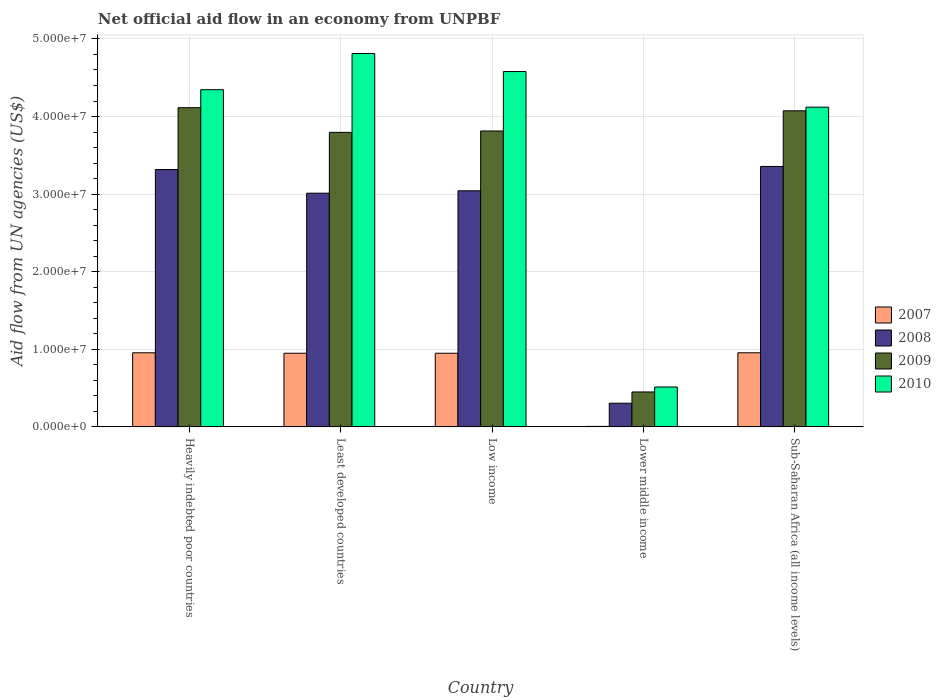How many groups of bars are there?
Keep it short and to the point. 5. What is the label of the 5th group of bars from the left?
Give a very brief answer. Sub-Saharan Africa (all income levels). What is the net official aid flow in 2008 in Sub-Saharan Africa (all income levels)?
Your answer should be compact. 3.36e+07. Across all countries, what is the maximum net official aid flow in 2009?
Your answer should be compact. 4.11e+07. Across all countries, what is the minimum net official aid flow in 2010?
Ensure brevity in your answer.  5.14e+06. In which country was the net official aid flow in 2007 maximum?
Keep it short and to the point. Heavily indebted poor countries. In which country was the net official aid flow in 2008 minimum?
Ensure brevity in your answer.  Lower middle income. What is the total net official aid flow in 2009 in the graph?
Make the answer very short. 1.62e+08. What is the difference between the net official aid flow in 2008 in Least developed countries and that in Sub-Saharan Africa (all income levels)?
Make the answer very short. -3.45e+06. What is the difference between the net official aid flow in 2010 in Heavily indebted poor countries and the net official aid flow in 2008 in Least developed countries?
Offer a very short reply. 1.33e+07. What is the average net official aid flow in 2009 per country?
Make the answer very short. 3.25e+07. What is the difference between the net official aid flow of/in 2010 and net official aid flow of/in 2009 in Low income?
Provide a succinct answer. 7.66e+06. In how many countries, is the net official aid flow in 2010 greater than 20000000 US$?
Offer a terse response. 4. What is the ratio of the net official aid flow in 2007 in Heavily indebted poor countries to that in Least developed countries?
Provide a succinct answer. 1.01. What is the difference between the highest and the second highest net official aid flow in 2007?
Ensure brevity in your answer.  6.00e+04. What is the difference between the highest and the lowest net official aid flow in 2009?
Provide a short and direct response. 3.66e+07. In how many countries, is the net official aid flow in 2009 greater than the average net official aid flow in 2009 taken over all countries?
Keep it short and to the point. 4. Is the sum of the net official aid flow in 2010 in Least developed countries and Sub-Saharan Africa (all income levels) greater than the maximum net official aid flow in 2009 across all countries?
Your response must be concise. Yes. Is it the case that in every country, the sum of the net official aid flow in 2008 and net official aid flow in 2007 is greater than the sum of net official aid flow in 2009 and net official aid flow in 2010?
Ensure brevity in your answer.  No. What does the 1st bar from the left in Sub-Saharan Africa (all income levels) represents?
Your answer should be compact. 2007. What does the 2nd bar from the right in Lower middle income represents?
Your answer should be very brief. 2009. How many bars are there?
Make the answer very short. 20. Are all the bars in the graph horizontal?
Provide a succinct answer. No. What is the difference between two consecutive major ticks on the Y-axis?
Provide a succinct answer. 1.00e+07. Where does the legend appear in the graph?
Provide a short and direct response. Center right. How are the legend labels stacked?
Your answer should be very brief. Vertical. What is the title of the graph?
Make the answer very short. Net official aid flow in an economy from UNPBF. Does "2014" appear as one of the legend labels in the graph?
Offer a terse response. No. What is the label or title of the Y-axis?
Offer a very short reply. Aid flow from UN agencies (US$). What is the Aid flow from UN agencies (US$) of 2007 in Heavily indebted poor countries?
Your response must be concise. 9.55e+06. What is the Aid flow from UN agencies (US$) of 2008 in Heavily indebted poor countries?
Ensure brevity in your answer.  3.32e+07. What is the Aid flow from UN agencies (US$) in 2009 in Heavily indebted poor countries?
Give a very brief answer. 4.11e+07. What is the Aid flow from UN agencies (US$) in 2010 in Heavily indebted poor countries?
Your answer should be compact. 4.35e+07. What is the Aid flow from UN agencies (US$) in 2007 in Least developed countries?
Your answer should be very brief. 9.49e+06. What is the Aid flow from UN agencies (US$) of 2008 in Least developed countries?
Give a very brief answer. 3.01e+07. What is the Aid flow from UN agencies (US$) in 2009 in Least developed countries?
Keep it short and to the point. 3.80e+07. What is the Aid flow from UN agencies (US$) in 2010 in Least developed countries?
Give a very brief answer. 4.81e+07. What is the Aid flow from UN agencies (US$) in 2007 in Low income?
Give a very brief answer. 9.49e+06. What is the Aid flow from UN agencies (US$) in 2008 in Low income?
Make the answer very short. 3.04e+07. What is the Aid flow from UN agencies (US$) in 2009 in Low income?
Offer a very short reply. 3.81e+07. What is the Aid flow from UN agencies (US$) in 2010 in Low income?
Your answer should be compact. 4.58e+07. What is the Aid flow from UN agencies (US$) in 2008 in Lower middle income?
Your answer should be very brief. 3.05e+06. What is the Aid flow from UN agencies (US$) of 2009 in Lower middle income?
Keep it short and to the point. 4.50e+06. What is the Aid flow from UN agencies (US$) in 2010 in Lower middle income?
Offer a very short reply. 5.14e+06. What is the Aid flow from UN agencies (US$) of 2007 in Sub-Saharan Africa (all income levels)?
Ensure brevity in your answer.  9.55e+06. What is the Aid flow from UN agencies (US$) of 2008 in Sub-Saharan Africa (all income levels)?
Give a very brief answer. 3.36e+07. What is the Aid flow from UN agencies (US$) in 2009 in Sub-Saharan Africa (all income levels)?
Your response must be concise. 4.07e+07. What is the Aid flow from UN agencies (US$) of 2010 in Sub-Saharan Africa (all income levels)?
Your answer should be very brief. 4.12e+07. Across all countries, what is the maximum Aid flow from UN agencies (US$) in 2007?
Your response must be concise. 9.55e+06. Across all countries, what is the maximum Aid flow from UN agencies (US$) of 2008?
Offer a terse response. 3.36e+07. Across all countries, what is the maximum Aid flow from UN agencies (US$) in 2009?
Your answer should be very brief. 4.11e+07. Across all countries, what is the maximum Aid flow from UN agencies (US$) of 2010?
Keep it short and to the point. 4.81e+07. Across all countries, what is the minimum Aid flow from UN agencies (US$) in 2008?
Your answer should be compact. 3.05e+06. Across all countries, what is the minimum Aid flow from UN agencies (US$) in 2009?
Offer a terse response. 4.50e+06. Across all countries, what is the minimum Aid flow from UN agencies (US$) of 2010?
Provide a short and direct response. 5.14e+06. What is the total Aid flow from UN agencies (US$) of 2007 in the graph?
Your response must be concise. 3.81e+07. What is the total Aid flow from UN agencies (US$) of 2008 in the graph?
Your answer should be compact. 1.30e+08. What is the total Aid flow from UN agencies (US$) of 2009 in the graph?
Offer a very short reply. 1.62e+08. What is the total Aid flow from UN agencies (US$) in 2010 in the graph?
Give a very brief answer. 1.84e+08. What is the difference between the Aid flow from UN agencies (US$) in 2008 in Heavily indebted poor countries and that in Least developed countries?
Give a very brief answer. 3.05e+06. What is the difference between the Aid flow from UN agencies (US$) in 2009 in Heavily indebted poor countries and that in Least developed countries?
Provide a short and direct response. 3.18e+06. What is the difference between the Aid flow from UN agencies (US$) in 2010 in Heavily indebted poor countries and that in Least developed countries?
Your response must be concise. -4.66e+06. What is the difference between the Aid flow from UN agencies (US$) in 2008 in Heavily indebted poor countries and that in Low income?
Your answer should be very brief. 2.74e+06. What is the difference between the Aid flow from UN agencies (US$) in 2009 in Heavily indebted poor countries and that in Low income?
Make the answer very short. 3.00e+06. What is the difference between the Aid flow from UN agencies (US$) of 2010 in Heavily indebted poor countries and that in Low income?
Offer a terse response. -2.34e+06. What is the difference between the Aid flow from UN agencies (US$) of 2007 in Heavily indebted poor countries and that in Lower middle income?
Your answer should be compact. 9.49e+06. What is the difference between the Aid flow from UN agencies (US$) in 2008 in Heavily indebted poor countries and that in Lower middle income?
Your response must be concise. 3.01e+07. What is the difference between the Aid flow from UN agencies (US$) of 2009 in Heavily indebted poor countries and that in Lower middle income?
Ensure brevity in your answer.  3.66e+07. What is the difference between the Aid flow from UN agencies (US$) in 2010 in Heavily indebted poor countries and that in Lower middle income?
Offer a terse response. 3.83e+07. What is the difference between the Aid flow from UN agencies (US$) in 2008 in Heavily indebted poor countries and that in Sub-Saharan Africa (all income levels)?
Offer a terse response. -4.00e+05. What is the difference between the Aid flow from UN agencies (US$) in 2009 in Heavily indebted poor countries and that in Sub-Saharan Africa (all income levels)?
Provide a succinct answer. 4.00e+05. What is the difference between the Aid flow from UN agencies (US$) of 2010 in Heavily indebted poor countries and that in Sub-Saharan Africa (all income levels)?
Your answer should be compact. 2.25e+06. What is the difference between the Aid flow from UN agencies (US$) of 2007 in Least developed countries and that in Low income?
Your response must be concise. 0. What is the difference between the Aid flow from UN agencies (US$) of 2008 in Least developed countries and that in Low income?
Your answer should be compact. -3.10e+05. What is the difference between the Aid flow from UN agencies (US$) of 2009 in Least developed countries and that in Low income?
Give a very brief answer. -1.80e+05. What is the difference between the Aid flow from UN agencies (US$) of 2010 in Least developed countries and that in Low income?
Your response must be concise. 2.32e+06. What is the difference between the Aid flow from UN agencies (US$) in 2007 in Least developed countries and that in Lower middle income?
Make the answer very short. 9.43e+06. What is the difference between the Aid flow from UN agencies (US$) in 2008 in Least developed countries and that in Lower middle income?
Provide a succinct answer. 2.71e+07. What is the difference between the Aid flow from UN agencies (US$) of 2009 in Least developed countries and that in Lower middle income?
Ensure brevity in your answer.  3.35e+07. What is the difference between the Aid flow from UN agencies (US$) of 2010 in Least developed countries and that in Lower middle income?
Your answer should be very brief. 4.30e+07. What is the difference between the Aid flow from UN agencies (US$) of 2007 in Least developed countries and that in Sub-Saharan Africa (all income levels)?
Offer a very short reply. -6.00e+04. What is the difference between the Aid flow from UN agencies (US$) of 2008 in Least developed countries and that in Sub-Saharan Africa (all income levels)?
Offer a very short reply. -3.45e+06. What is the difference between the Aid flow from UN agencies (US$) in 2009 in Least developed countries and that in Sub-Saharan Africa (all income levels)?
Your response must be concise. -2.78e+06. What is the difference between the Aid flow from UN agencies (US$) in 2010 in Least developed countries and that in Sub-Saharan Africa (all income levels)?
Your answer should be compact. 6.91e+06. What is the difference between the Aid flow from UN agencies (US$) of 2007 in Low income and that in Lower middle income?
Your answer should be very brief. 9.43e+06. What is the difference between the Aid flow from UN agencies (US$) of 2008 in Low income and that in Lower middle income?
Offer a very short reply. 2.74e+07. What is the difference between the Aid flow from UN agencies (US$) in 2009 in Low income and that in Lower middle income?
Give a very brief answer. 3.36e+07. What is the difference between the Aid flow from UN agencies (US$) of 2010 in Low income and that in Lower middle income?
Your response must be concise. 4.07e+07. What is the difference between the Aid flow from UN agencies (US$) in 2007 in Low income and that in Sub-Saharan Africa (all income levels)?
Your response must be concise. -6.00e+04. What is the difference between the Aid flow from UN agencies (US$) in 2008 in Low income and that in Sub-Saharan Africa (all income levels)?
Your answer should be compact. -3.14e+06. What is the difference between the Aid flow from UN agencies (US$) of 2009 in Low income and that in Sub-Saharan Africa (all income levels)?
Keep it short and to the point. -2.60e+06. What is the difference between the Aid flow from UN agencies (US$) in 2010 in Low income and that in Sub-Saharan Africa (all income levels)?
Your response must be concise. 4.59e+06. What is the difference between the Aid flow from UN agencies (US$) of 2007 in Lower middle income and that in Sub-Saharan Africa (all income levels)?
Your answer should be very brief. -9.49e+06. What is the difference between the Aid flow from UN agencies (US$) in 2008 in Lower middle income and that in Sub-Saharan Africa (all income levels)?
Keep it short and to the point. -3.05e+07. What is the difference between the Aid flow from UN agencies (US$) of 2009 in Lower middle income and that in Sub-Saharan Africa (all income levels)?
Your answer should be very brief. -3.62e+07. What is the difference between the Aid flow from UN agencies (US$) in 2010 in Lower middle income and that in Sub-Saharan Africa (all income levels)?
Keep it short and to the point. -3.61e+07. What is the difference between the Aid flow from UN agencies (US$) of 2007 in Heavily indebted poor countries and the Aid flow from UN agencies (US$) of 2008 in Least developed countries?
Give a very brief answer. -2.06e+07. What is the difference between the Aid flow from UN agencies (US$) in 2007 in Heavily indebted poor countries and the Aid flow from UN agencies (US$) in 2009 in Least developed countries?
Keep it short and to the point. -2.84e+07. What is the difference between the Aid flow from UN agencies (US$) of 2007 in Heavily indebted poor countries and the Aid flow from UN agencies (US$) of 2010 in Least developed countries?
Offer a very short reply. -3.86e+07. What is the difference between the Aid flow from UN agencies (US$) in 2008 in Heavily indebted poor countries and the Aid flow from UN agencies (US$) in 2009 in Least developed countries?
Offer a very short reply. -4.79e+06. What is the difference between the Aid flow from UN agencies (US$) of 2008 in Heavily indebted poor countries and the Aid flow from UN agencies (US$) of 2010 in Least developed countries?
Your answer should be very brief. -1.50e+07. What is the difference between the Aid flow from UN agencies (US$) of 2009 in Heavily indebted poor countries and the Aid flow from UN agencies (US$) of 2010 in Least developed countries?
Provide a short and direct response. -6.98e+06. What is the difference between the Aid flow from UN agencies (US$) of 2007 in Heavily indebted poor countries and the Aid flow from UN agencies (US$) of 2008 in Low income?
Provide a short and direct response. -2.09e+07. What is the difference between the Aid flow from UN agencies (US$) of 2007 in Heavily indebted poor countries and the Aid flow from UN agencies (US$) of 2009 in Low income?
Your answer should be very brief. -2.86e+07. What is the difference between the Aid flow from UN agencies (US$) in 2007 in Heavily indebted poor countries and the Aid flow from UN agencies (US$) in 2010 in Low income?
Provide a short and direct response. -3.62e+07. What is the difference between the Aid flow from UN agencies (US$) in 2008 in Heavily indebted poor countries and the Aid flow from UN agencies (US$) in 2009 in Low income?
Your response must be concise. -4.97e+06. What is the difference between the Aid flow from UN agencies (US$) of 2008 in Heavily indebted poor countries and the Aid flow from UN agencies (US$) of 2010 in Low income?
Offer a very short reply. -1.26e+07. What is the difference between the Aid flow from UN agencies (US$) in 2009 in Heavily indebted poor countries and the Aid flow from UN agencies (US$) in 2010 in Low income?
Provide a succinct answer. -4.66e+06. What is the difference between the Aid flow from UN agencies (US$) of 2007 in Heavily indebted poor countries and the Aid flow from UN agencies (US$) of 2008 in Lower middle income?
Provide a succinct answer. 6.50e+06. What is the difference between the Aid flow from UN agencies (US$) in 2007 in Heavily indebted poor countries and the Aid flow from UN agencies (US$) in 2009 in Lower middle income?
Your answer should be compact. 5.05e+06. What is the difference between the Aid flow from UN agencies (US$) in 2007 in Heavily indebted poor countries and the Aid flow from UN agencies (US$) in 2010 in Lower middle income?
Provide a succinct answer. 4.41e+06. What is the difference between the Aid flow from UN agencies (US$) in 2008 in Heavily indebted poor countries and the Aid flow from UN agencies (US$) in 2009 in Lower middle income?
Give a very brief answer. 2.87e+07. What is the difference between the Aid flow from UN agencies (US$) in 2008 in Heavily indebted poor countries and the Aid flow from UN agencies (US$) in 2010 in Lower middle income?
Your answer should be very brief. 2.80e+07. What is the difference between the Aid flow from UN agencies (US$) in 2009 in Heavily indebted poor countries and the Aid flow from UN agencies (US$) in 2010 in Lower middle income?
Ensure brevity in your answer.  3.60e+07. What is the difference between the Aid flow from UN agencies (US$) of 2007 in Heavily indebted poor countries and the Aid flow from UN agencies (US$) of 2008 in Sub-Saharan Africa (all income levels)?
Ensure brevity in your answer.  -2.40e+07. What is the difference between the Aid flow from UN agencies (US$) in 2007 in Heavily indebted poor countries and the Aid flow from UN agencies (US$) in 2009 in Sub-Saharan Africa (all income levels)?
Your answer should be very brief. -3.12e+07. What is the difference between the Aid flow from UN agencies (US$) of 2007 in Heavily indebted poor countries and the Aid flow from UN agencies (US$) of 2010 in Sub-Saharan Africa (all income levels)?
Ensure brevity in your answer.  -3.17e+07. What is the difference between the Aid flow from UN agencies (US$) in 2008 in Heavily indebted poor countries and the Aid flow from UN agencies (US$) in 2009 in Sub-Saharan Africa (all income levels)?
Ensure brevity in your answer.  -7.57e+06. What is the difference between the Aid flow from UN agencies (US$) in 2008 in Heavily indebted poor countries and the Aid flow from UN agencies (US$) in 2010 in Sub-Saharan Africa (all income levels)?
Offer a terse response. -8.04e+06. What is the difference between the Aid flow from UN agencies (US$) of 2009 in Heavily indebted poor countries and the Aid flow from UN agencies (US$) of 2010 in Sub-Saharan Africa (all income levels)?
Provide a short and direct response. -7.00e+04. What is the difference between the Aid flow from UN agencies (US$) in 2007 in Least developed countries and the Aid flow from UN agencies (US$) in 2008 in Low income?
Keep it short and to the point. -2.09e+07. What is the difference between the Aid flow from UN agencies (US$) in 2007 in Least developed countries and the Aid flow from UN agencies (US$) in 2009 in Low income?
Ensure brevity in your answer.  -2.86e+07. What is the difference between the Aid flow from UN agencies (US$) of 2007 in Least developed countries and the Aid flow from UN agencies (US$) of 2010 in Low income?
Make the answer very short. -3.63e+07. What is the difference between the Aid flow from UN agencies (US$) in 2008 in Least developed countries and the Aid flow from UN agencies (US$) in 2009 in Low income?
Ensure brevity in your answer.  -8.02e+06. What is the difference between the Aid flow from UN agencies (US$) of 2008 in Least developed countries and the Aid flow from UN agencies (US$) of 2010 in Low income?
Keep it short and to the point. -1.57e+07. What is the difference between the Aid flow from UN agencies (US$) in 2009 in Least developed countries and the Aid flow from UN agencies (US$) in 2010 in Low income?
Your response must be concise. -7.84e+06. What is the difference between the Aid flow from UN agencies (US$) of 2007 in Least developed countries and the Aid flow from UN agencies (US$) of 2008 in Lower middle income?
Your response must be concise. 6.44e+06. What is the difference between the Aid flow from UN agencies (US$) of 2007 in Least developed countries and the Aid flow from UN agencies (US$) of 2009 in Lower middle income?
Your response must be concise. 4.99e+06. What is the difference between the Aid flow from UN agencies (US$) in 2007 in Least developed countries and the Aid flow from UN agencies (US$) in 2010 in Lower middle income?
Offer a very short reply. 4.35e+06. What is the difference between the Aid flow from UN agencies (US$) in 2008 in Least developed countries and the Aid flow from UN agencies (US$) in 2009 in Lower middle income?
Your answer should be very brief. 2.56e+07. What is the difference between the Aid flow from UN agencies (US$) of 2008 in Least developed countries and the Aid flow from UN agencies (US$) of 2010 in Lower middle income?
Give a very brief answer. 2.50e+07. What is the difference between the Aid flow from UN agencies (US$) of 2009 in Least developed countries and the Aid flow from UN agencies (US$) of 2010 in Lower middle income?
Your answer should be very brief. 3.28e+07. What is the difference between the Aid flow from UN agencies (US$) of 2007 in Least developed countries and the Aid flow from UN agencies (US$) of 2008 in Sub-Saharan Africa (all income levels)?
Ensure brevity in your answer.  -2.41e+07. What is the difference between the Aid flow from UN agencies (US$) of 2007 in Least developed countries and the Aid flow from UN agencies (US$) of 2009 in Sub-Saharan Africa (all income levels)?
Provide a short and direct response. -3.12e+07. What is the difference between the Aid flow from UN agencies (US$) of 2007 in Least developed countries and the Aid flow from UN agencies (US$) of 2010 in Sub-Saharan Africa (all income levels)?
Give a very brief answer. -3.17e+07. What is the difference between the Aid flow from UN agencies (US$) of 2008 in Least developed countries and the Aid flow from UN agencies (US$) of 2009 in Sub-Saharan Africa (all income levels)?
Make the answer very short. -1.06e+07. What is the difference between the Aid flow from UN agencies (US$) of 2008 in Least developed countries and the Aid flow from UN agencies (US$) of 2010 in Sub-Saharan Africa (all income levels)?
Provide a short and direct response. -1.11e+07. What is the difference between the Aid flow from UN agencies (US$) in 2009 in Least developed countries and the Aid flow from UN agencies (US$) in 2010 in Sub-Saharan Africa (all income levels)?
Offer a terse response. -3.25e+06. What is the difference between the Aid flow from UN agencies (US$) of 2007 in Low income and the Aid flow from UN agencies (US$) of 2008 in Lower middle income?
Ensure brevity in your answer.  6.44e+06. What is the difference between the Aid flow from UN agencies (US$) of 2007 in Low income and the Aid flow from UN agencies (US$) of 2009 in Lower middle income?
Make the answer very short. 4.99e+06. What is the difference between the Aid flow from UN agencies (US$) in 2007 in Low income and the Aid flow from UN agencies (US$) in 2010 in Lower middle income?
Offer a very short reply. 4.35e+06. What is the difference between the Aid flow from UN agencies (US$) in 2008 in Low income and the Aid flow from UN agencies (US$) in 2009 in Lower middle income?
Provide a succinct answer. 2.59e+07. What is the difference between the Aid flow from UN agencies (US$) of 2008 in Low income and the Aid flow from UN agencies (US$) of 2010 in Lower middle income?
Your answer should be very brief. 2.53e+07. What is the difference between the Aid flow from UN agencies (US$) of 2009 in Low income and the Aid flow from UN agencies (US$) of 2010 in Lower middle income?
Your answer should be compact. 3.30e+07. What is the difference between the Aid flow from UN agencies (US$) of 2007 in Low income and the Aid flow from UN agencies (US$) of 2008 in Sub-Saharan Africa (all income levels)?
Offer a terse response. -2.41e+07. What is the difference between the Aid flow from UN agencies (US$) in 2007 in Low income and the Aid flow from UN agencies (US$) in 2009 in Sub-Saharan Africa (all income levels)?
Keep it short and to the point. -3.12e+07. What is the difference between the Aid flow from UN agencies (US$) of 2007 in Low income and the Aid flow from UN agencies (US$) of 2010 in Sub-Saharan Africa (all income levels)?
Your answer should be very brief. -3.17e+07. What is the difference between the Aid flow from UN agencies (US$) of 2008 in Low income and the Aid flow from UN agencies (US$) of 2009 in Sub-Saharan Africa (all income levels)?
Give a very brief answer. -1.03e+07. What is the difference between the Aid flow from UN agencies (US$) of 2008 in Low income and the Aid flow from UN agencies (US$) of 2010 in Sub-Saharan Africa (all income levels)?
Give a very brief answer. -1.08e+07. What is the difference between the Aid flow from UN agencies (US$) of 2009 in Low income and the Aid flow from UN agencies (US$) of 2010 in Sub-Saharan Africa (all income levels)?
Make the answer very short. -3.07e+06. What is the difference between the Aid flow from UN agencies (US$) of 2007 in Lower middle income and the Aid flow from UN agencies (US$) of 2008 in Sub-Saharan Africa (all income levels)?
Keep it short and to the point. -3.35e+07. What is the difference between the Aid flow from UN agencies (US$) of 2007 in Lower middle income and the Aid flow from UN agencies (US$) of 2009 in Sub-Saharan Africa (all income levels)?
Offer a terse response. -4.07e+07. What is the difference between the Aid flow from UN agencies (US$) of 2007 in Lower middle income and the Aid flow from UN agencies (US$) of 2010 in Sub-Saharan Africa (all income levels)?
Give a very brief answer. -4.12e+07. What is the difference between the Aid flow from UN agencies (US$) of 2008 in Lower middle income and the Aid flow from UN agencies (US$) of 2009 in Sub-Saharan Africa (all income levels)?
Offer a very short reply. -3.77e+07. What is the difference between the Aid flow from UN agencies (US$) of 2008 in Lower middle income and the Aid flow from UN agencies (US$) of 2010 in Sub-Saharan Africa (all income levels)?
Offer a very short reply. -3.82e+07. What is the difference between the Aid flow from UN agencies (US$) in 2009 in Lower middle income and the Aid flow from UN agencies (US$) in 2010 in Sub-Saharan Africa (all income levels)?
Provide a succinct answer. -3.67e+07. What is the average Aid flow from UN agencies (US$) of 2007 per country?
Keep it short and to the point. 7.63e+06. What is the average Aid flow from UN agencies (US$) of 2008 per country?
Keep it short and to the point. 2.61e+07. What is the average Aid flow from UN agencies (US$) of 2009 per country?
Keep it short and to the point. 3.25e+07. What is the average Aid flow from UN agencies (US$) in 2010 per country?
Offer a very short reply. 3.67e+07. What is the difference between the Aid flow from UN agencies (US$) in 2007 and Aid flow from UN agencies (US$) in 2008 in Heavily indebted poor countries?
Your answer should be very brief. -2.36e+07. What is the difference between the Aid flow from UN agencies (US$) in 2007 and Aid flow from UN agencies (US$) in 2009 in Heavily indebted poor countries?
Your response must be concise. -3.16e+07. What is the difference between the Aid flow from UN agencies (US$) of 2007 and Aid flow from UN agencies (US$) of 2010 in Heavily indebted poor countries?
Ensure brevity in your answer.  -3.39e+07. What is the difference between the Aid flow from UN agencies (US$) in 2008 and Aid flow from UN agencies (US$) in 2009 in Heavily indebted poor countries?
Make the answer very short. -7.97e+06. What is the difference between the Aid flow from UN agencies (US$) of 2008 and Aid flow from UN agencies (US$) of 2010 in Heavily indebted poor countries?
Make the answer very short. -1.03e+07. What is the difference between the Aid flow from UN agencies (US$) of 2009 and Aid flow from UN agencies (US$) of 2010 in Heavily indebted poor countries?
Your response must be concise. -2.32e+06. What is the difference between the Aid flow from UN agencies (US$) in 2007 and Aid flow from UN agencies (US$) in 2008 in Least developed countries?
Your answer should be very brief. -2.06e+07. What is the difference between the Aid flow from UN agencies (US$) in 2007 and Aid flow from UN agencies (US$) in 2009 in Least developed countries?
Your answer should be very brief. -2.85e+07. What is the difference between the Aid flow from UN agencies (US$) of 2007 and Aid flow from UN agencies (US$) of 2010 in Least developed countries?
Provide a short and direct response. -3.86e+07. What is the difference between the Aid flow from UN agencies (US$) of 2008 and Aid flow from UN agencies (US$) of 2009 in Least developed countries?
Provide a succinct answer. -7.84e+06. What is the difference between the Aid flow from UN agencies (US$) in 2008 and Aid flow from UN agencies (US$) in 2010 in Least developed countries?
Your response must be concise. -1.80e+07. What is the difference between the Aid flow from UN agencies (US$) of 2009 and Aid flow from UN agencies (US$) of 2010 in Least developed countries?
Ensure brevity in your answer.  -1.02e+07. What is the difference between the Aid flow from UN agencies (US$) in 2007 and Aid flow from UN agencies (US$) in 2008 in Low income?
Make the answer very short. -2.09e+07. What is the difference between the Aid flow from UN agencies (US$) in 2007 and Aid flow from UN agencies (US$) in 2009 in Low income?
Provide a short and direct response. -2.86e+07. What is the difference between the Aid flow from UN agencies (US$) of 2007 and Aid flow from UN agencies (US$) of 2010 in Low income?
Your response must be concise. -3.63e+07. What is the difference between the Aid flow from UN agencies (US$) in 2008 and Aid flow from UN agencies (US$) in 2009 in Low income?
Your response must be concise. -7.71e+06. What is the difference between the Aid flow from UN agencies (US$) in 2008 and Aid flow from UN agencies (US$) in 2010 in Low income?
Your answer should be compact. -1.54e+07. What is the difference between the Aid flow from UN agencies (US$) in 2009 and Aid flow from UN agencies (US$) in 2010 in Low income?
Provide a succinct answer. -7.66e+06. What is the difference between the Aid flow from UN agencies (US$) of 2007 and Aid flow from UN agencies (US$) of 2008 in Lower middle income?
Your answer should be compact. -2.99e+06. What is the difference between the Aid flow from UN agencies (US$) in 2007 and Aid flow from UN agencies (US$) in 2009 in Lower middle income?
Ensure brevity in your answer.  -4.44e+06. What is the difference between the Aid flow from UN agencies (US$) in 2007 and Aid flow from UN agencies (US$) in 2010 in Lower middle income?
Give a very brief answer. -5.08e+06. What is the difference between the Aid flow from UN agencies (US$) in 2008 and Aid flow from UN agencies (US$) in 2009 in Lower middle income?
Your response must be concise. -1.45e+06. What is the difference between the Aid flow from UN agencies (US$) in 2008 and Aid flow from UN agencies (US$) in 2010 in Lower middle income?
Your answer should be very brief. -2.09e+06. What is the difference between the Aid flow from UN agencies (US$) of 2009 and Aid flow from UN agencies (US$) of 2010 in Lower middle income?
Offer a very short reply. -6.40e+05. What is the difference between the Aid flow from UN agencies (US$) in 2007 and Aid flow from UN agencies (US$) in 2008 in Sub-Saharan Africa (all income levels)?
Ensure brevity in your answer.  -2.40e+07. What is the difference between the Aid flow from UN agencies (US$) of 2007 and Aid flow from UN agencies (US$) of 2009 in Sub-Saharan Africa (all income levels)?
Give a very brief answer. -3.12e+07. What is the difference between the Aid flow from UN agencies (US$) in 2007 and Aid flow from UN agencies (US$) in 2010 in Sub-Saharan Africa (all income levels)?
Keep it short and to the point. -3.17e+07. What is the difference between the Aid flow from UN agencies (US$) of 2008 and Aid flow from UN agencies (US$) of 2009 in Sub-Saharan Africa (all income levels)?
Your answer should be very brief. -7.17e+06. What is the difference between the Aid flow from UN agencies (US$) of 2008 and Aid flow from UN agencies (US$) of 2010 in Sub-Saharan Africa (all income levels)?
Offer a very short reply. -7.64e+06. What is the difference between the Aid flow from UN agencies (US$) of 2009 and Aid flow from UN agencies (US$) of 2010 in Sub-Saharan Africa (all income levels)?
Provide a short and direct response. -4.70e+05. What is the ratio of the Aid flow from UN agencies (US$) in 2007 in Heavily indebted poor countries to that in Least developed countries?
Your response must be concise. 1.01. What is the ratio of the Aid flow from UN agencies (US$) in 2008 in Heavily indebted poor countries to that in Least developed countries?
Your answer should be compact. 1.1. What is the ratio of the Aid flow from UN agencies (US$) in 2009 in Heavily indebted poor countries to that in Least developed countries?
Your response must be concise. 1.08. What is the ratio of the Aid flow from UN agencies (US$) of 2010 in Heavily indebted poor countries to that in Least developed countries?
Provide a succinct answer. 0.9. What is the ratio of the Aid flow from UN agencies (US$) of 2007 in Heavily indebted poor countries to that in Low income?
Provide a succinct answer. 1.01. What is the ratio of the Aid flow from UN agencies (US$) in 2008 in Heavily indebted poor countries to that in Low income?
Ensure brevity in your answer.  1.09. What is the ratio of the Aid flow from UN agencies (US$) of 2009 in Heavily indebted poor countries to that in Low income?
Offer a terse response. 1.08. What is the ratio of the Aid flow from UN agencies (US$) of 2010 in Heavily indebted poor countries to that in Low income?
Offer a terse response. 0.95. What is the ratio of the Aid flow from UN agencies (US$) of 2007 in Heavily indebted poor countries to that in Lower middle income?
Provide a short and direct response. 159.17. What is the ratio of the Aid flow from UN agencies (US$) in 2008 in Heavily indebted poor countries to that in Lower middle income?
Provide a succinct answer. 10.88. What is the ratio of the Aid flow from UN agencies (US$) of 2009 in Heavily indebted poor countries to that in Lower middle income?
Offer a terse response. 9.14. What is the ratio of the Aid flow from UN agencies (US$) in 2010 in Heavily indebted poor countries to that in Lower middle income?
Offer a terse response. 8.46. What is the ratio of the Aid flow from UN agencies (US$) in 2007 in Heavily indebted poor countries to that in Sub-Saharan Africa (all income levels)?
Provide a short and direct response. 1. What is the ratio of the Aid flow from UN agencies (US$) in 2008 in Heavily indebted poor countries to that in Sub-Saharan Africa (all income levels)?
Give a very brief answer. 0.99. What is the ratio of the Aid flow from UN agencies (US$) of 2009 in Heavily indebted poor countries to that in Sub-Saharan Africa (all income levels)?
Ensure brevity in your answer.  1.01. What is the ratio of the Aid flow from UN agencies (US$) of 2010 in Heavily indebted poor countries to that in Sub-Saharan Africa (all income levels)?
Offer a very short reply. 1.05. What is the ratio of the Aid flow from UN agencies (US$) of 2008 in Least developed countries to that in Low income?
Give a very brief answer. 0.99. What is the ratio of the Aid flow from UN agencies (US$) in 2009 in Least developed countries to that in Low income?
Keep it short and to the point. 1. What is the ratio of the Aid flow from UN agencies (US$) in 2010 in Least developed countries to that in Low income?
Your answer should be very brief. 1.05. What is the ratio of the Aid flow from UN agencies (US$) in 2007 in Least developed countries to that in Lower middle income?
Your response must be concise. 158.17. What is the ratio of the Aid flow from UN agencies (US$) of 2008 in Least developed countries to that in Lower middle income?
Offer a terse response. 9.88. What is the ratio of the Aid flow from UN agencies (US$) in 2009 in Least developed countries to that in Lower middle income?
Offer a terse response. 8.44. What is the ratio of the Aid flow from UN agencies (US$) of 2010 in Least developed countries to that in Lower middle income?
Keep it short and to the point. 9.36. What is the ratio of the Aid flow from UN agencies (US$) in 2007 in Least developed countries to that in Sub-Saharan Africa (all income levels)?
Your answer should be very brief. 0.99. What is the ratio of the Aid flow from UN agencies (US$) in 2008 in Least developed countries to that in Sub-Saharan Africa (all income levels)?
Offer a terse response. 0.9. What is the ratio of the Aid flow from UN agencies (US$) of 2009 in Least developed countries to that in Sub-Saharan Africa (all income levels)?
Your answer should be compact. 0.93. What is the ratio of the Aid flow from UN agencies (US$) in 2010 in Least developed countries to that in Sub-Saharan Africa (all income levels)?
Your answer should be very brief. 1.17. What is the ratio of the Aid flow from UN agencies (US$) in 2007 in Low income to that in Lower middle income?
Your answer should be compact. 158.17. What is the ratio of the Aid flow from UN agencies (US$) of 2008 in Low income to that in Lower middle income?
Keep it short and to the point. 9.98. What is the ratio of the Aid flow from UN agencies (US$) in 2009 in Low income to that in Lower middle income?
Your answer should be compact. 8.48. What is the ratio of the Aid flow from UN agencies (US$) of 2010 in Low income to that in Lower middle income?
Your answer should be compact. 8.91. What is the ratio of the Aid flow from UN agencies (US$) in 2008 in Low income to that in Sub-Saharan Africa (all income levels)?
Make the answer very short. 0.91. What is the ratio of the Aid flow from UN agencies (US$) in 2009 in Low income to that in Sub-Saharan Africa (all income levels)?
Your answer should be very brief. 0.94. What is the ratio of the Aid flow from UN agencies (US$) in 2010 in Low income to that in Sub-Saharan Africa (all income levels)?
Your response must be concise. 1.11. What is the ratio of the Aid flow from UN agencies (US$) in 2007 in Lower middle income to that in Sub-Saharan Africa (all income levels)?
Your answer should be very brief. 0.01. What is the ratio of the Aid flow from UN agencies (US$) in 2008 in Lower middle income to that in Sub-Saharan Africa (all income levels)?
Your response must be concise. 0.09. What is the ratio of the Aid flow from UN agencies (US$) of 2009 in Lower middle income to that in Sub-Saharan Africa (all income levels)?
Make the answer very short. 0.11. What is the ratio of the Aid flow from UN agencies (US$) of 2010 in Lower middle income to that in Sub-Saharan Africa (all income levels)?
Your answer should be compact. 0.12. What is the difference between the highest and the second highest Aid flow from UN agencies (US$) of 2009?
Provide a short and direct response. 4.00e+05. What is the difference between the highest and the second highest Aid flow from UN agencies (US$) of 2010?
Give a very brief answer. 2.32e+06. What is the difference between the highest and the lowest Aid flow from UN agencies (US$) in 2007?
Your answer should be very brief. 9.49e+06. What is the difference between the highest and the lowest Aid flow from UN agencies (US$) in 2008?
Your answer should be very brief. 3.05e+07. What is the difference between the highest and the lowest Aid flow from UN agencies (US$) in 2009?
Give a very brief answer. 3.66e+07. What is the difference between the highest and the lowest Aid flow from UN agencies (US$) in 2010?
Provide a short and direct response. 4.30e+07. 